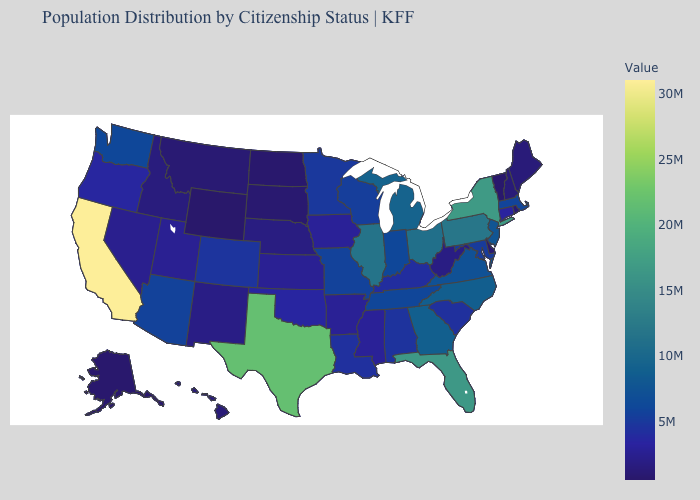Does South Carolina have the lowest value in the South?
Concise answer only. No. Does Oregon have the highest value in the USA?
Concise answer only. No. Among the states that border Wyoming , does South Dakota have the lowest value?
Keep it brief. Yes. Which states have the lowest value in the USA?
Give a very brief answer. Wyoming. Does California have the highest value in the West?
Short answer required. Yes. Among the states that border Connecticut , does Massachusetts have the highest value?
Quick response, please. No. Does California have the highest value in the USA?
Answer briefly. Yes. 